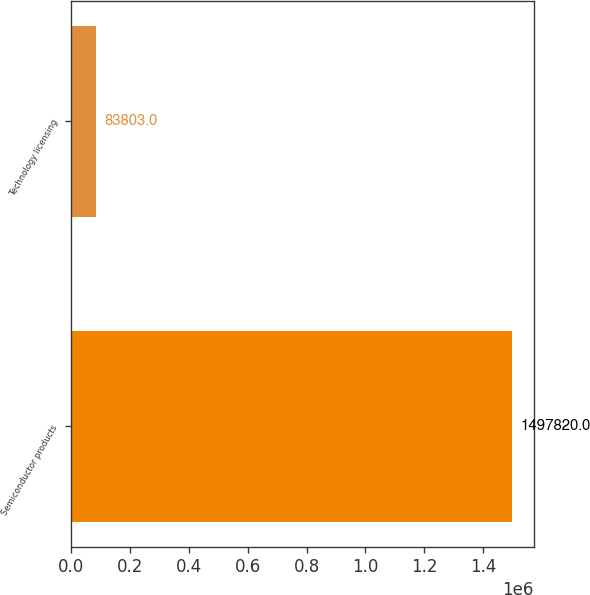<chart> <loc_0><loc_0><loc_500><loc_500><bar_chart><fcel>Semiconductor products<fcel>Technology licensing<nl><fcel>1.49782e+06<fcel>83803<nl></chart> 